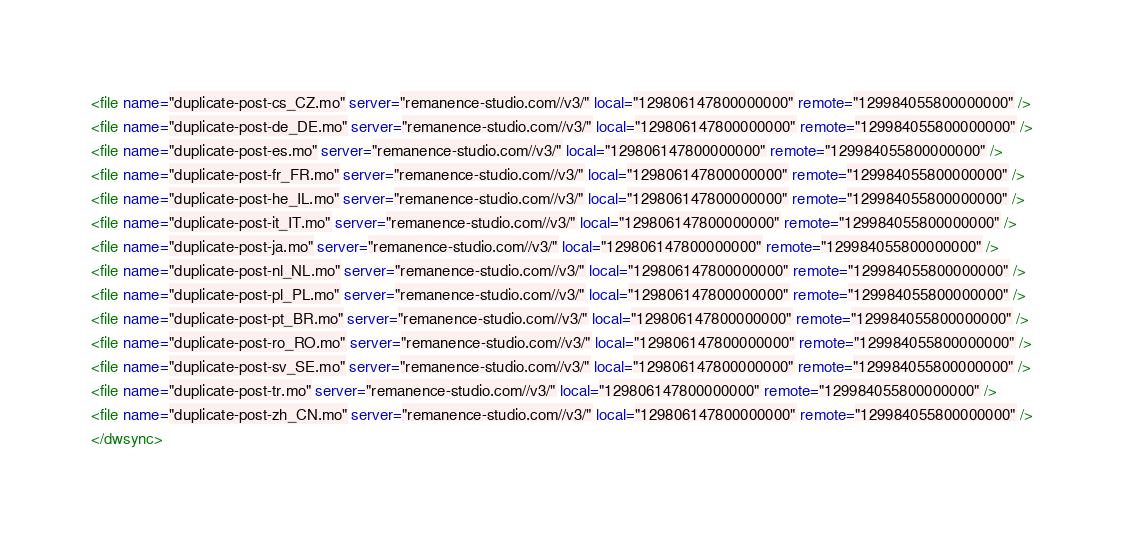Convert code to text. <code><loc_0><loc_0><loc_500><loc_500><_XML_><file name="duplicate-post-cs_CZ.mo" server="remanence-studio.com//v3/" local="129806147800000000" remote="129984055800000000" />
<file name="duplicate-post-de_DE.mo" server="remanence-studio.com//v3/" local="129806147800000000" remote="129984055800000000" />
<file name="duplicate-post-es.mo" server="remanence-studio.com//v3/" local="129806147800000000" remote="129984055800000000" />
<file name="duplicate-post-fr_FR.mo" server="remanence-studio.com//v3/" local="129806147800000000" remote="129984055800000000" />
<file name="duplicate-post-he_IL.mo" server="remanence-studio.com//v3/" local="129806147800000000" remote="129984055800000000" />
<file name="duplicate-post-it_IT.mo" server="remanence-studio.com//v3/" local="129806147800000000" remote="129984055800000000" />
<file name="duplicate-post-ja.mo" server="remanence-studio.com//v3/" local="129806147800000000" remote="129984055800000000" />
<file name="duplicate-post-nl_NL.mo" server="remanence-studio.com//v3/" local="129806147800000000" remote="129984055800000000" />
<file name="duplicate-post-pl_PL.mo" server="remanence-studio.com//v3/" local="129806147800000000" remote="129984055800000000" />
<file name="duplicate-post-pt_BR.mo" server="remanence-studio.com//v3/" local="129806147800000000" remote="129984055800000000" />
<file name="duplicate-post-ro_RO.mo" server="remanence-studio.com//v3/" local="129806147800000000" remote="129984055800000000" />
<file name="duplicate-post-sv_SE.mo" server="remanence-studio.com//v3/" local="129806147800000000" remote="129984055800000000" />
<file name="duplicate-post-tr.mo" server="remanence-studio.com//v3/" local="129806147800000000" remote="129984055800000000" />
<file name="duplicate-post-zh_CN.mo" server="remanence-studio.com//v3/" local="129806147800000000" remote="129984055800000000" />
</dwsync></code> 